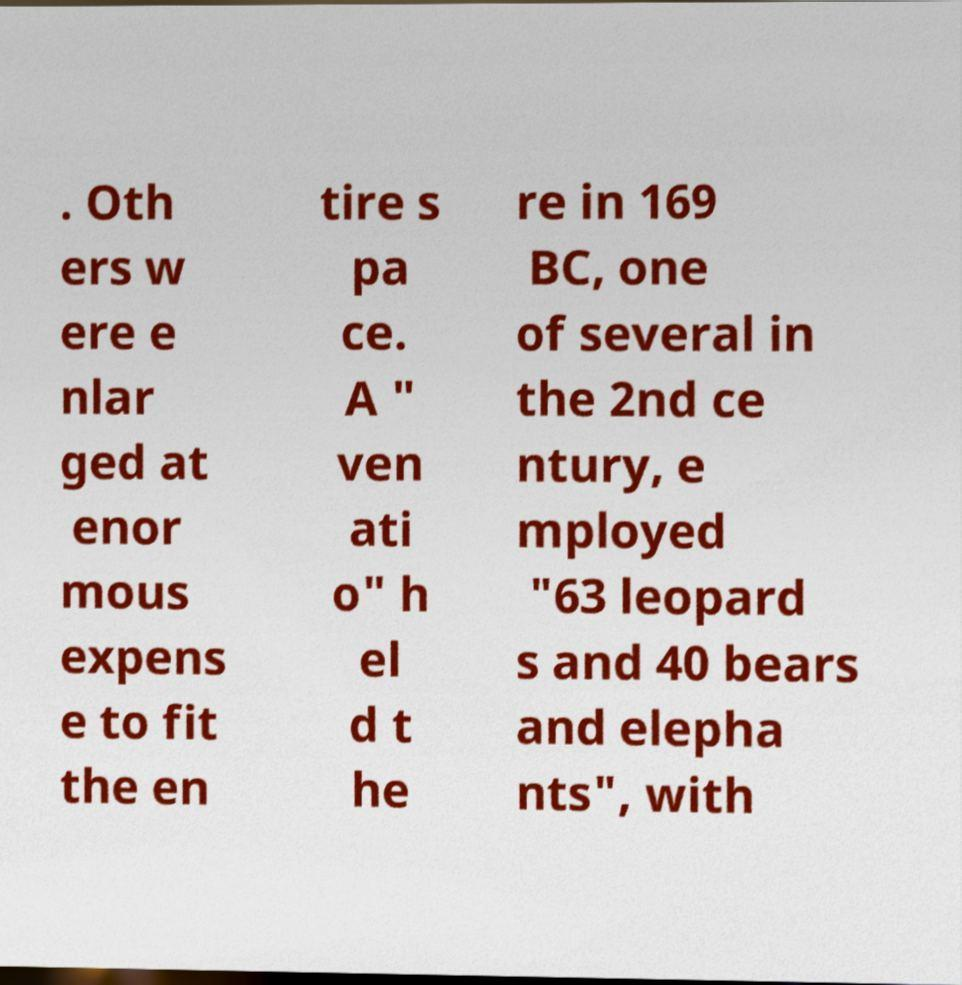Could you assist in decoding the text presented in this image and type it out clearly? . Oth ers w ere e nlar ged at enor mous expens e to fit the en tire s pa ce. A " ven ati o" h el d t he re in 169 BC, one of several in the 2nd ce ntury, e mployed "63 leopard s and 40 bears and elepha nts", with 